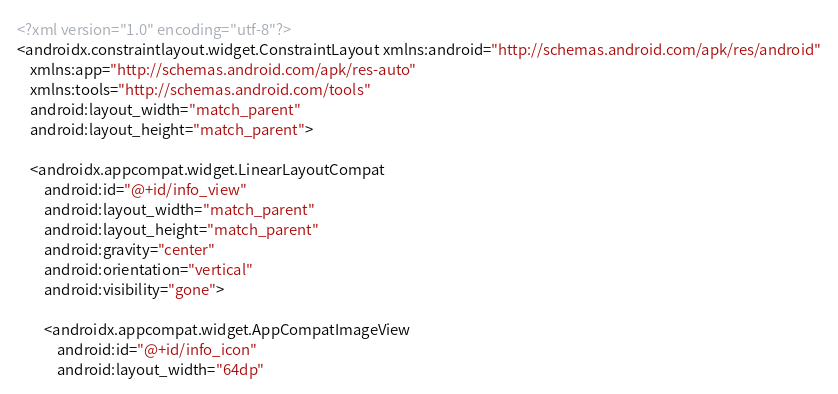<code> <loc_0><loc_0><loc_500><loc_500><_XML_><?xml version="1.0" encoding="utf-8"?>
<androidx.constraintlayout.widget.ConstraintLayout xmlns:android="http://schemas.android.com/apk/res/android"
    xmlns:app="http://schemas.android.com/apk/res-auto"
    xmlns:tools="http://schemas.android.com/tools"
    android:layout_width="match_parent"
    android:layout_height="match_parent">

    <androidx.appcompat.widget.LinearLayoutCompat
        android:id="@+id/info_view"
        android:layout_width="match_parent"
        android:layout_height="match_parent"
        android:gravity="center"
        android:orientation="vertical"
        android:visibility="gone">

        <androidx.appcompat.widget.AppCompatImageView
            android:id="@+id/info_icon"
            android:layout_width="64dp"</code> 